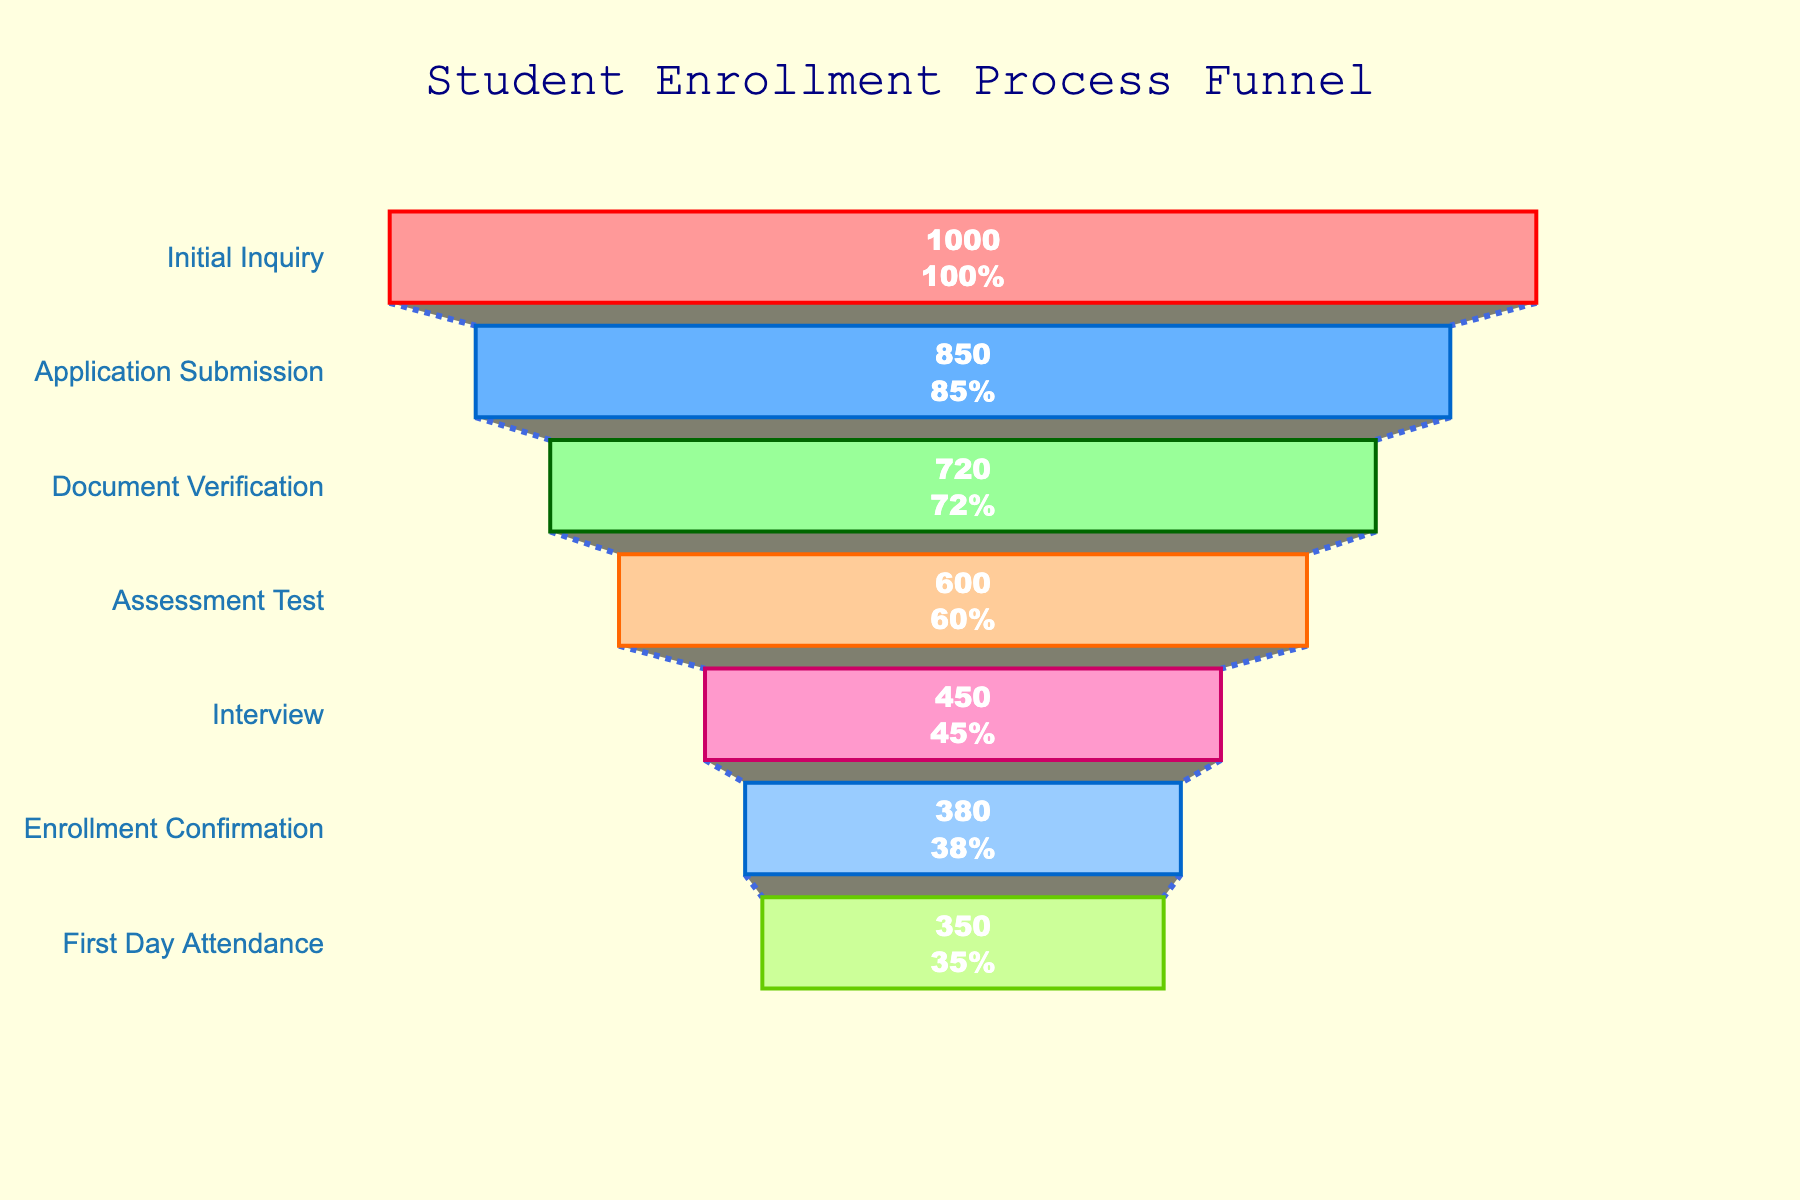what is the title of the plot? The title of the plot is displayed at the top of the figure; it reads "Student Enrollment Process Funnel".
Answer: Student Enrollment Process Funnel How many stages are shown in the enrollment process? Counting the different stages listed on the funnel, there are 7 stages in total.
Answer: 7 What's the conversion rate from Initial Inquiry to Application Submission? The conversion rate is determined by dividing the number of students at Application Submission (850) by the number of students at Initial Inquiry (1000) and then multiplying by 100. The calculation is (850/1000) * 100 = 85%.
Answer: 85% Which stage has the highest drop-off in students? By comparing the differences in student numbers between consecutive stages, the largest drop-off occurs between Assessment Test (600) and Interview (450), which is a drop of 150 students.
Answer: Assessment Test to Interview How many students finally attended the first day? The plot shows that the total number of students present on the first day of attendance is given directly; this value is 350 students.
Answer: 350 What's the difference in the number of students between Document Verification and Interview stages? To find the difference, subtract the number of students at the Interview stage (450) from the number at the Document Verification stage (720). The calculation is 720 - 450 = 270.
Answer: 270 Which stage has the lowest conversion rate relative to the previous stage? To determine the lowest conversion rate, we compare each stage's conversion rate relative to the previous one. The lowest is from Interview (450) to Enrollment Confirmation (380), calculated as (380/450) * 100 ≈ 84.44%.
Answer: Interview to Enrollment Confirmation What percentage of students reached the Enrollment Confirmation stage out of the Initial Inquiries? The percentage is calculated by dividing the number of students at the Enrollment Confirmation stage (380) by the Initial Inquiries (1000) and multiplying by 100. The calculation is (380/1000) * 100 = 38%.
Answer: 38% Which color scheme is used in the funnel chart? The funnel chart uses a gradient color scheme with colors such as light red, blue, green, and others, representing different stages.
Answer: Gradient color scheme What percentage of initial inquiries did not make it to the first day? To find the percentage, subtract the number of students on the first day (350) from the initial inquiries (1000), then divide by the initial inquiries and multiply by 100. The calculation is ((1000 - 350) / 1000) * 100 = 65%.
Answer: 65% 